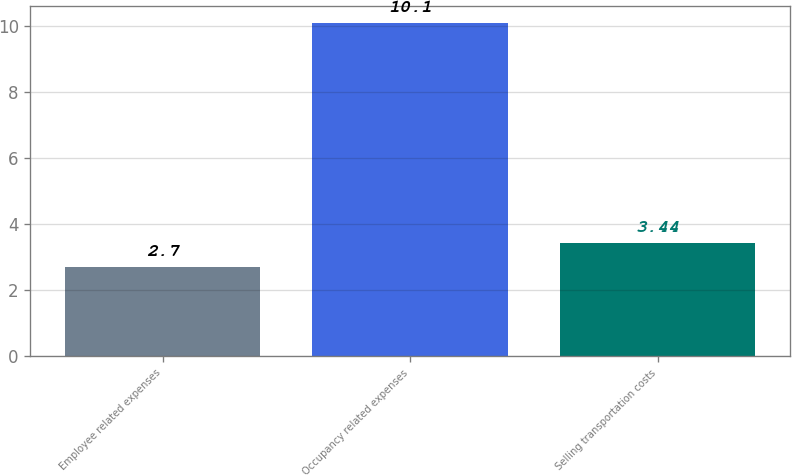Convert chart to OTSL. <chart><loc_0><loc_0><loc_500><loc_500><bar_chart><fcel>Employee related expenses<fcel>Occupancy related expenses<fcel>Selling transportation costs<nl><fcel>2.7<fcel>10.1<fcel>3.44<nl></chart> 